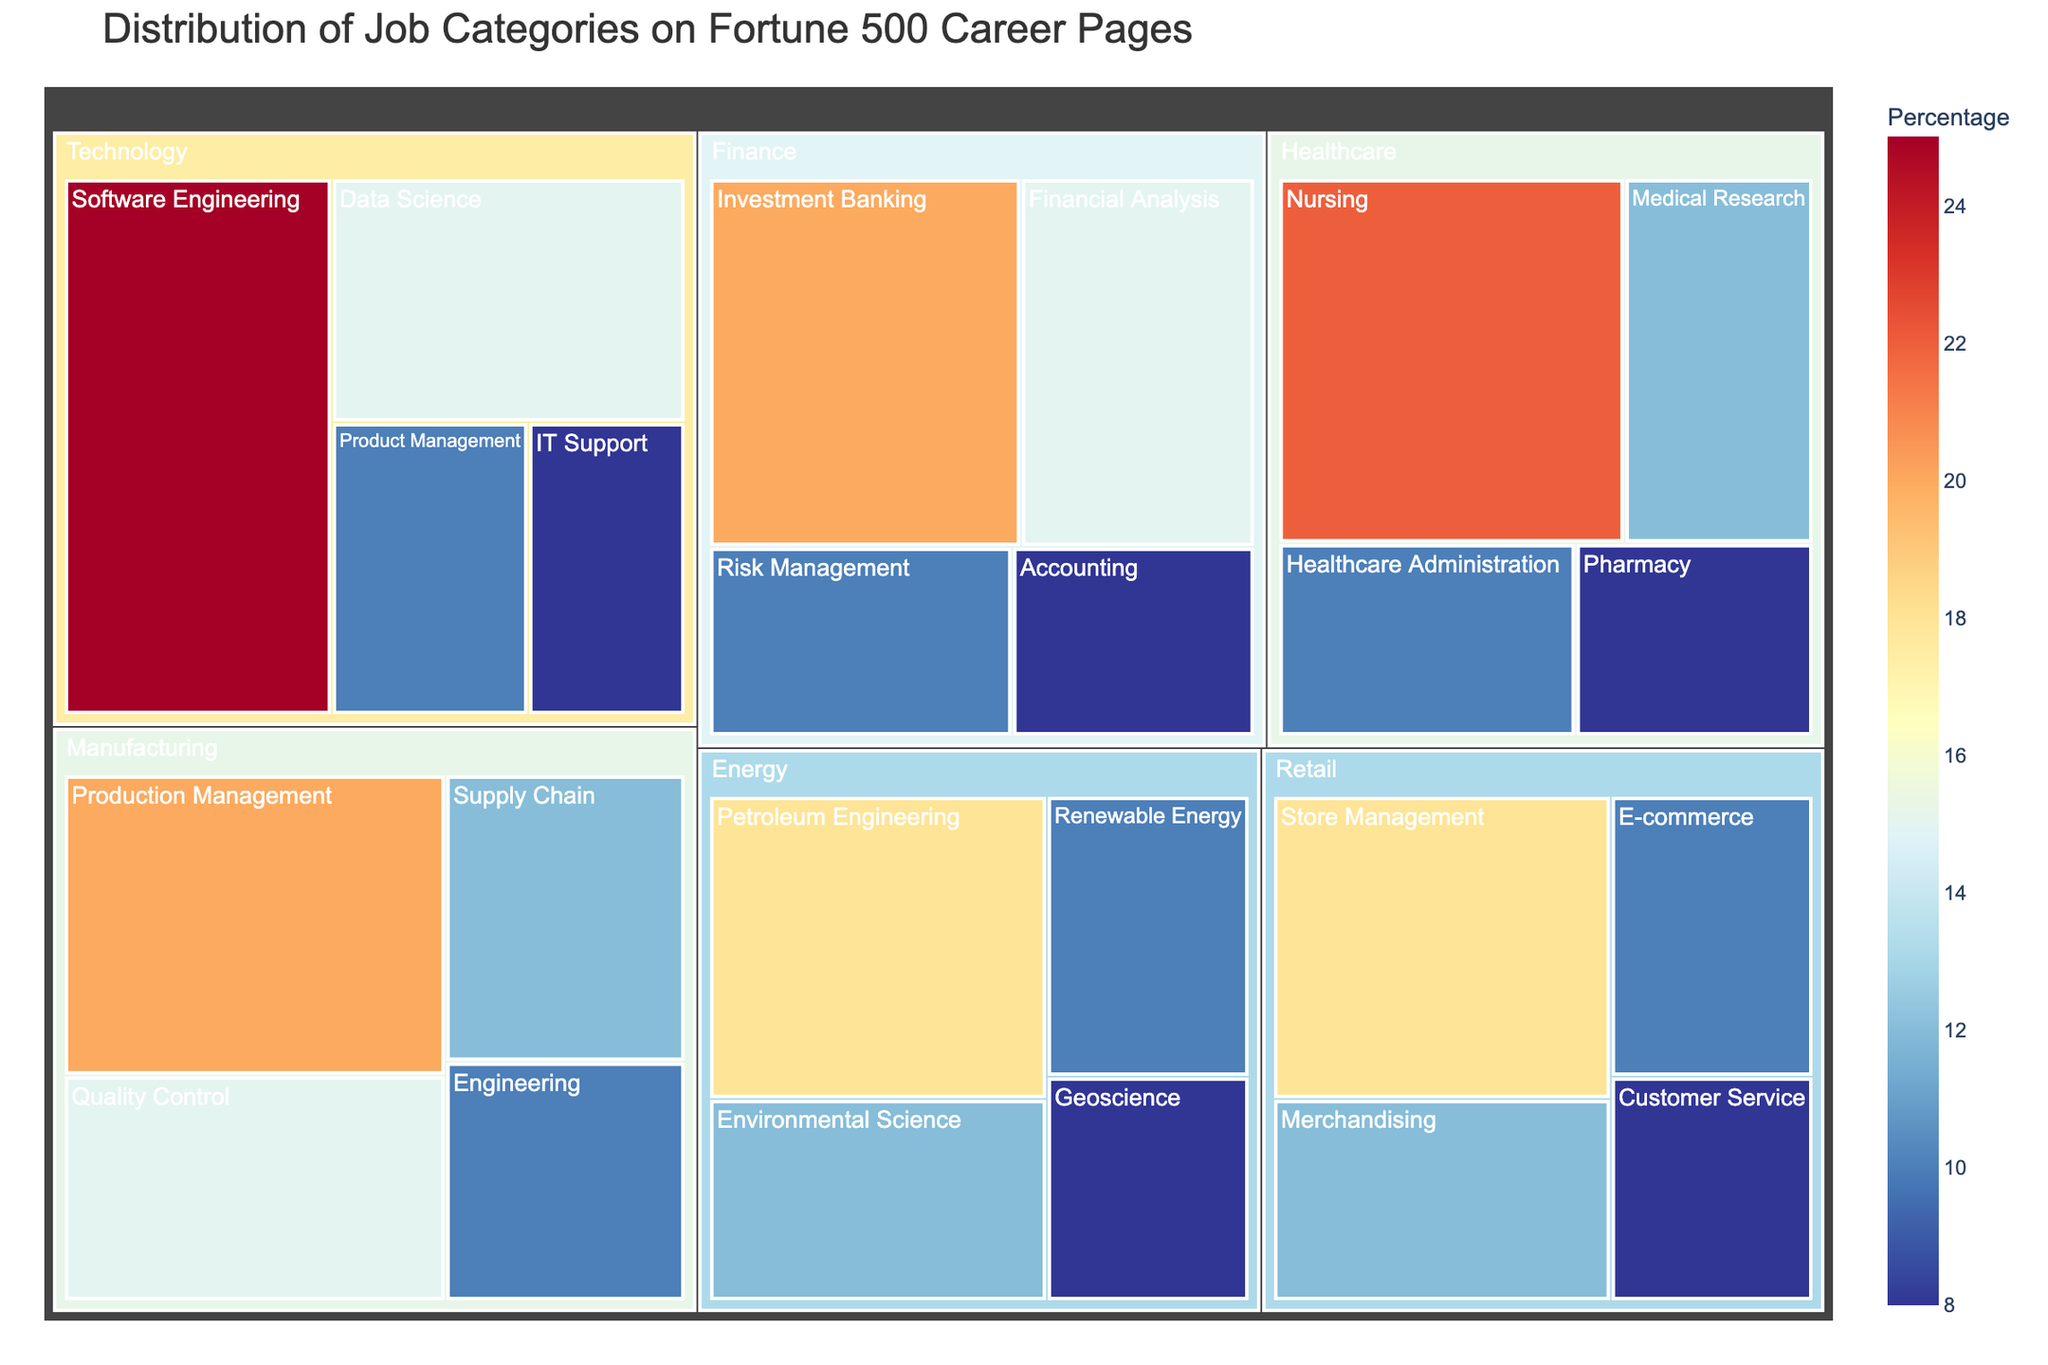Which industry has the job category with the highest percentage? By inspecting the largest section within each industry, it is evident that the 'Software Engineering' category under 'Technology' has the highest percentage at 25%.
Answer: Technology What is the combined percentage of 'Data Science' and 'Financial Analysis' job categories? From inspecting the treemap, the 'Data Science' category has 15% and 'Financial Analysis' has 15%. Adding these together, 15% + 15% = 30%.
Answer: 30% In the 'Retail' industry, which job category has the lowest percentage? By examining the 'Retail' sections in the treemap, 'Customer Service' has the smallest allocation, marked at 8%.
Answer: Customer Service Compare the percentages of 'Nursing' in 'Healthcare' and 'Investment Banking' in 'Finance'. Which is higher and by how much? 'Nursing' in 'Healthcare' is 22% and 'Investment Banking' in 'Finance' is 20%. Calculating the difference, 22% - 20% = 2%. Thus, 'Nursing' is higher by 2%.
Answer: Nursing is higher by 2% What is the percentage difference between 'Production Management' in 'Manufacturing' and 'Store Management' in 'Retail'? 'Production Management' is 20% and 'Store Management' is 18%. The percentage difference is 20% - 18% = 2%.
Answer: 2% What percentage of job categories have a value less than 10%? Observing the treemap, the categories: IT Support (8%), Accounting (8%), Pharmacy (8%), Customer Service (8%), Geoscience (8%) comprise the total count of 10%.
Answer: 5 categories Which industry has job categories summing up to the highest percentage, and what is that total percentage? By summing the percentages for each industry, 'Technology' sums to (25% + 15% + 10% + 8%) = 58%. Therefore, 'Technology' has the highest total percentage.
Answer: Technology, 58% What is the average percentage of the job categories within the 'Energy' industry? Adding the 'Energy' industry percentages: (18% + 12% + 10% + 8%) = 48%. There are 4 job categories, so the average is 48% / 4 = 12%.
Answer: 12% Between 'Quality Control' in 'Manufacturing' and 'Product Management' in 'Technology', which job category has a higher percentage? 'Quality Control' in 'Manufacturing' has a percentage of 15% while 'Product Management' in 'Technology' has 10%. Hence, 'Quality Control' is higher.
Answer: Quality Control 